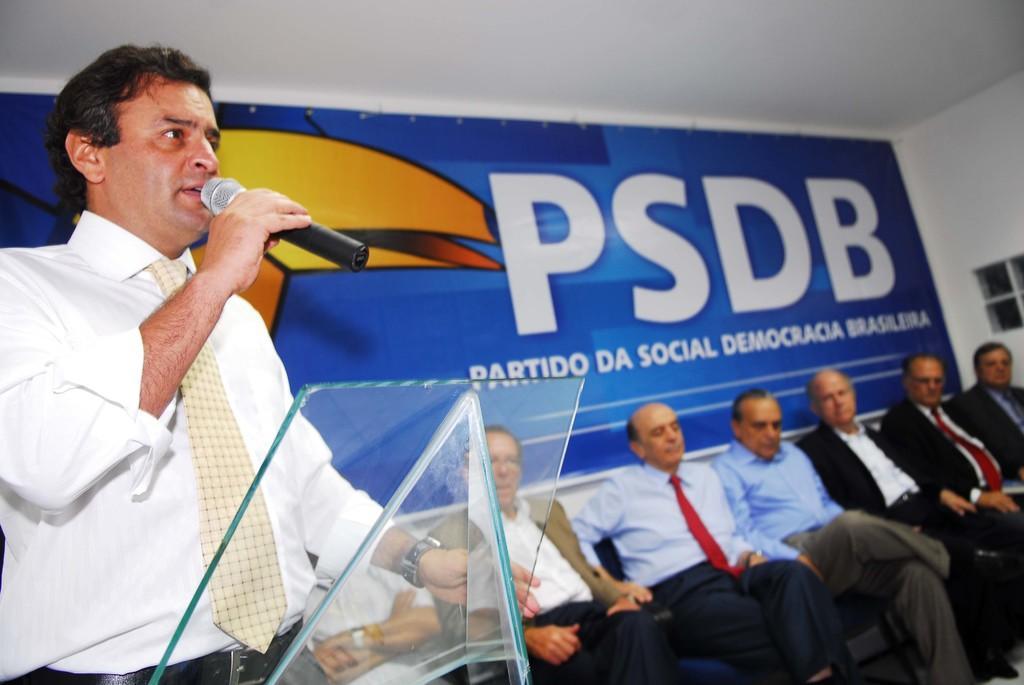Describe this image in one or two sentences. In this image there are a few men sitting on the chairs. To the left there is a man standing. In front of him there is a glass podium. He is holding a microphone in his hand. Behind them there is a wall. There is a banner on the wall. There is text on the banner. 